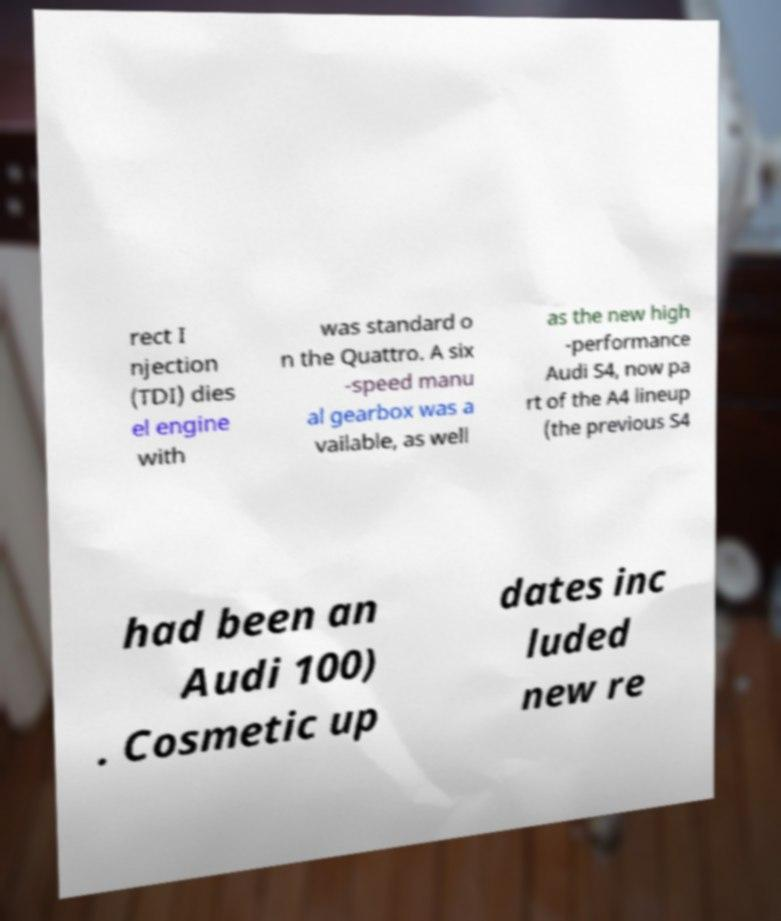I need the written content from this picture converted into text. Can you do that? rect I njection (TDI) dies el engine with was standard o n the Quattro. A six -speed manu al gearbox was a vailable, as well as the new high -performance Audi S4, now pa rt of the A4 lineup (the previous S4 had been an Audi 100) . Cosmetic up dates inc luded new re 